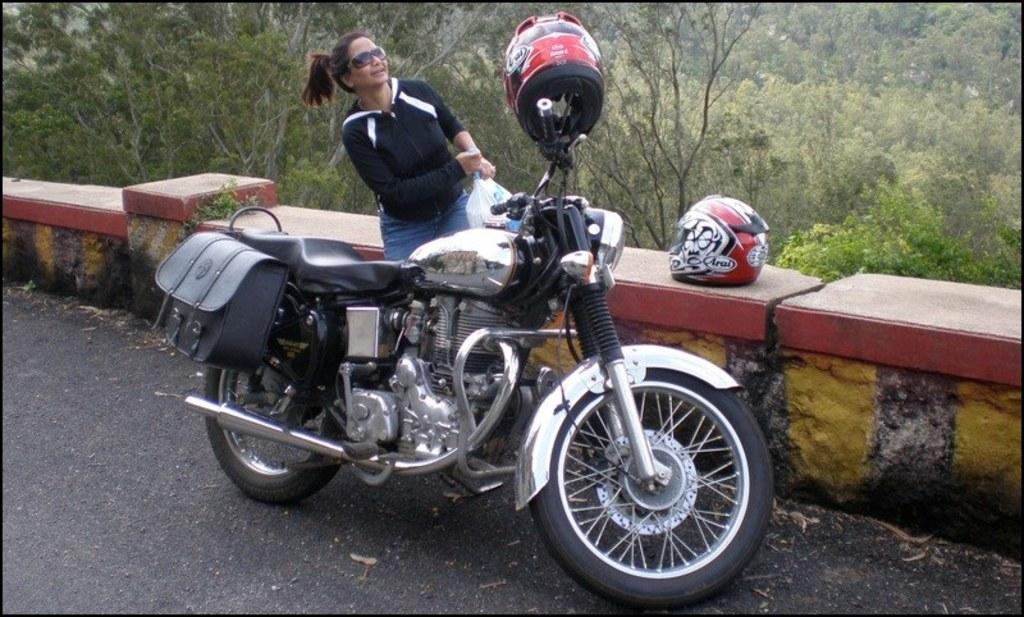Who is present in the image? There is a woman in the image. What object is visible in the image that is commonly used for transportation? There is a bike in the image. What item can be seen in the image that might be used for carrying personal belongings? There is a bag in the image. What is covering the bike in the image? There is a plastic cover in the image. What safety equipment is present in the image? There are helmets in the image. What type of surface is visible in the image? There is a road in the image. What architectural feature is present in the image? There is a wall in the image. What can be seen in the background of the image that indicates the presence of nature? There are trees in the background of the image. What type of chess piece can be seen on the wall in the image? There is no chess piece present on the wall in the image. What type of wing is visible on the woman in the image? The woman in the image does not have any wings. 